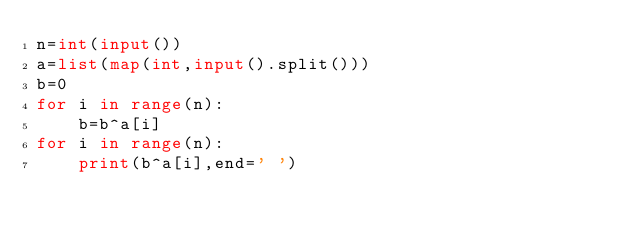Convert code to text. <code><loc_0><loc_0><loc_500><loc_500><_Python_>n=int(input())
a=list(map(int,input().split()))
b=0
for i in range(n):
    b=b^a[i]
for i in range(n):
    print(b^a[i],end=' ')</code> 